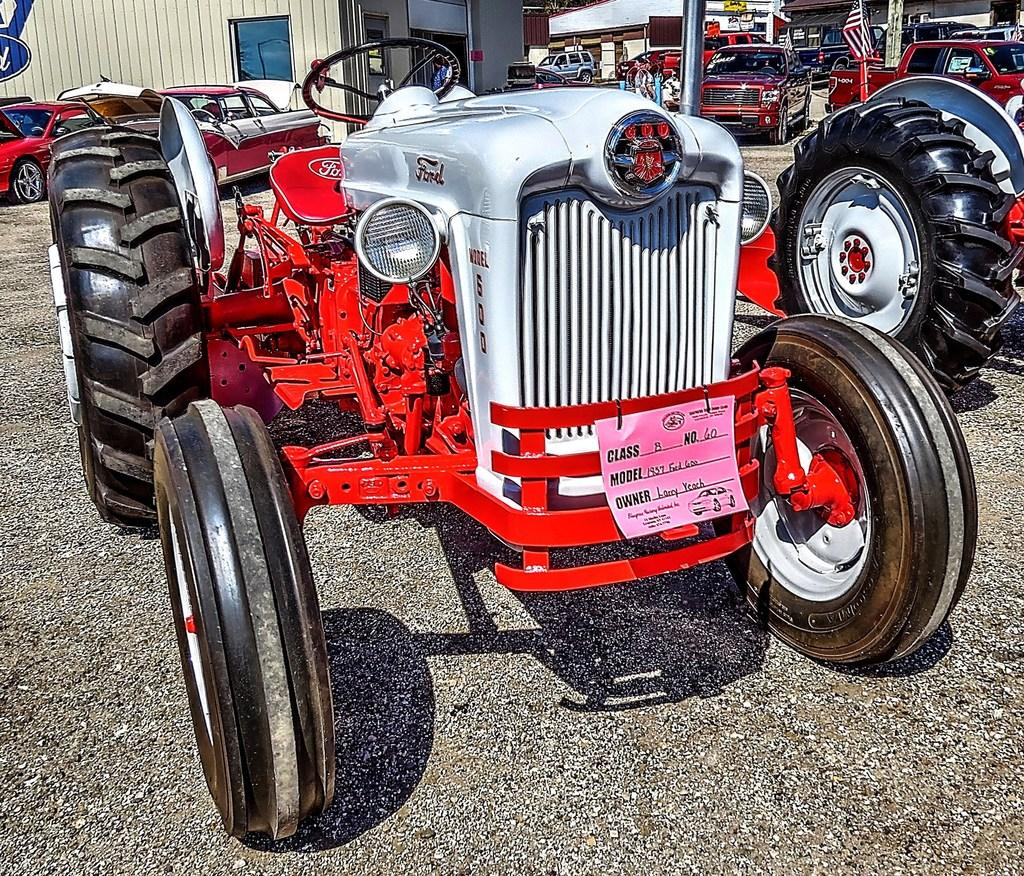What types of objects are on the ground in the image? There are vehicles on the ground in the image. What can be seen in the distance behind the vehicles? There are buildings visible in the background of the image. What is the object with a specific design and colors in the image? There is a flag in the image. Who or what is present in the image besides the vehicles and buildings? There is a person in the image. Where is the vase located in the image? There is no vase present in the image. What type of dirt can be seen on the person's shoes in the image? There is no dirt visible on the person's shoes in the image. 